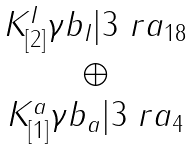<formula> <loc_0><loc_0><loc_500><loc_500>\begin{matrix} K _ { [ 2 ] } ^ { I } \gamma b _ { I } | 3 \ r a _ { 1 8 } \\ \oplus \\ K _ { [ 1 ] } ^ { a } \gamma b _ { a } | 3 \ r a _ { 4 } \end{matrix}</formula> 